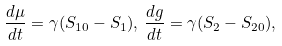<formula> <loc_0><loc_0><loc_500><loc_500>\frac { d \mu } { d t } = \gamma ( S _ { 1 0 } - S _ { 1 } ) , \, \frac { d g } { d t } = \gamma ( S _ { 2 } - S _ { 2 0 } ) ,</formula> 